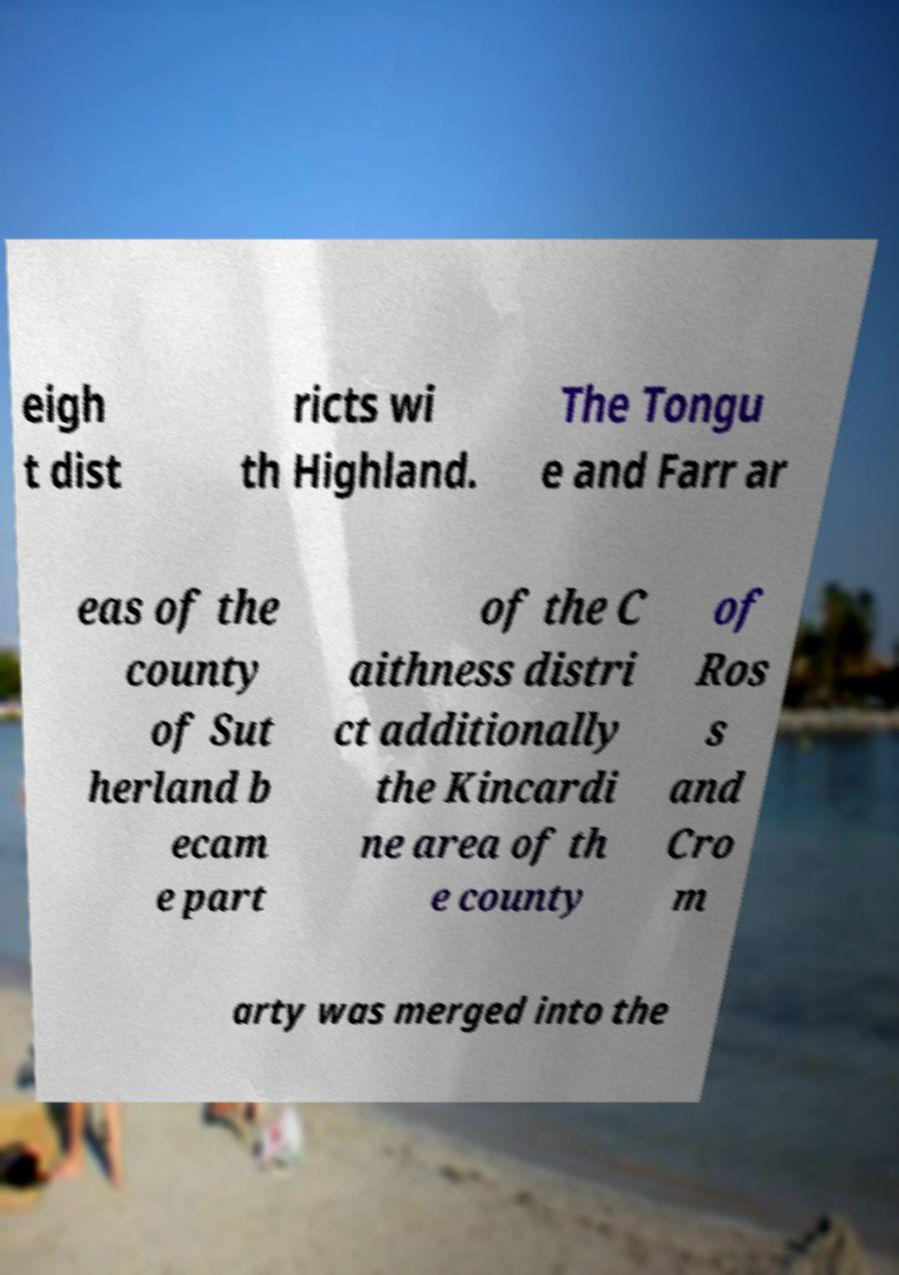There's text embedded in this image that I need extracted. Can you transcribe it verbatim? eigh t dist ricts wi th Highland. The Tongu e and Farr ar eas of the county of Sut herland b ecam e part of the C aithness distri ct additionally the Kincardi ne area of th e county of Ros s and Cro m arty was merged into the 